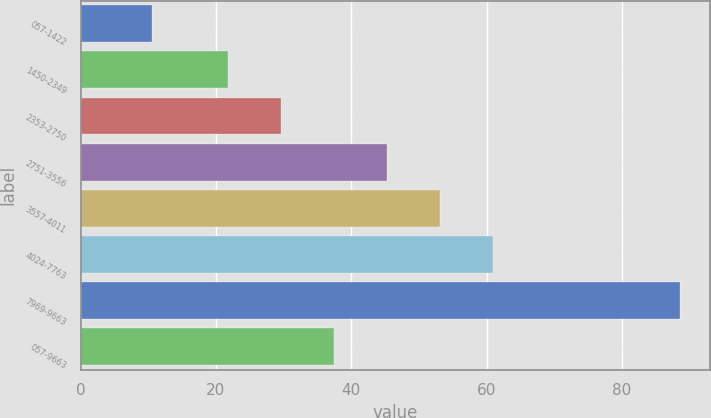Convert chart. <chart><loc_0><loc_0><loc_500><loc_500><bar_chart><fcel>057-1422<fcel>1450-2349<fcel>2353-2750<fcel>2751-3556<fcel>3557-4011<fcel>4024-7763<fcel>7969-9663<fcel>057-9663<nl><fcel>10.5<fcel>21.85<fcel>29.66<fcel>45.28<fcel>53.09<fcel>60.9<fcel>88.62<fcel>37.47<nl></chart> 